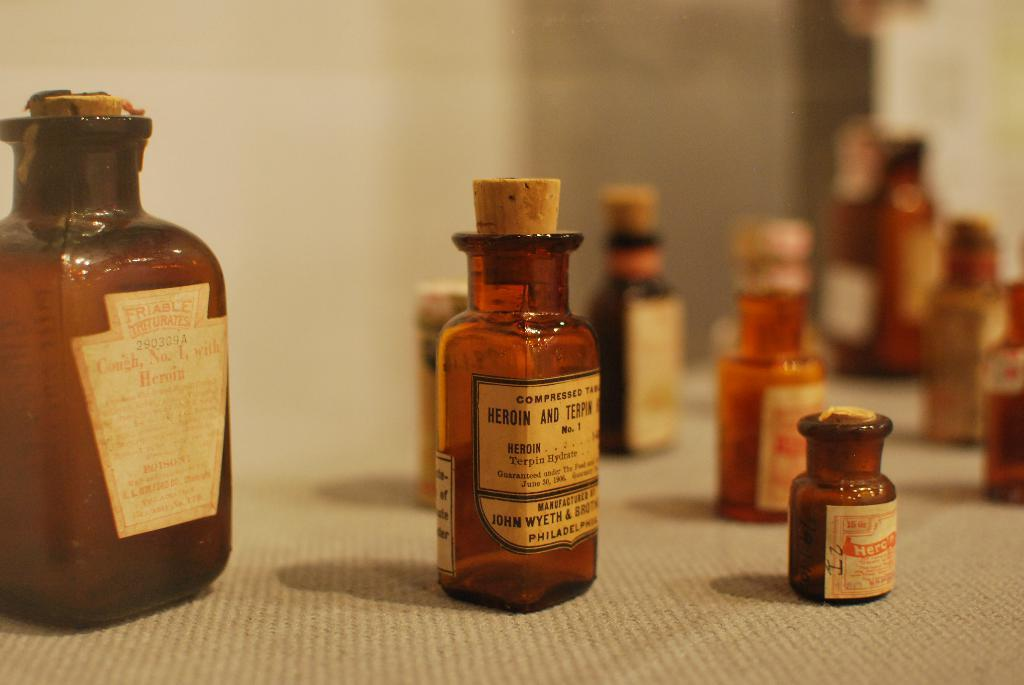What piece of furniture is present in the image? There is a table in the image. What objects are placed on the table? There are many bottles on the table. How many boys are playing with the flower in the image? There is no boy or flower present in the image. 